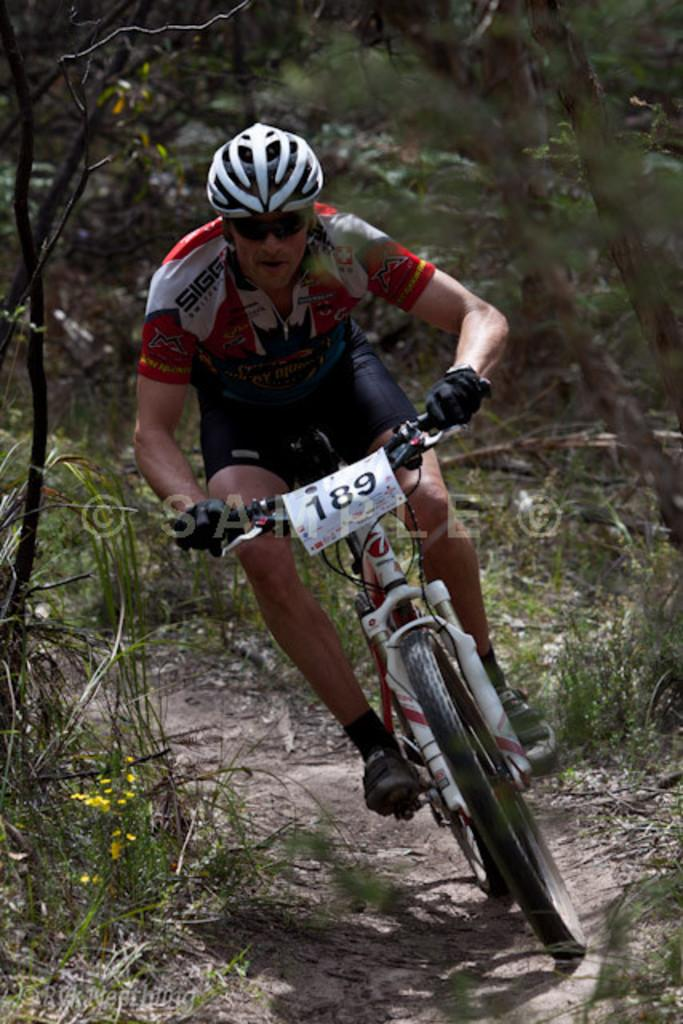What is the man in the image wearing on his head? The man is wearing a helmet in the image. What is the man wearing to protect his eyes? The man is wearing goggles in the image. What type of footwear is the man wearing? The man is wearing shoes in the image. What is the man doing in the image? The man is riding a bicycle in the image. What is the position of the bicycle in the image? The bicycle is on the ground in the image. What can be seen in the background of the image? There are trees in the background of the image. What type of copper material is present in the image? There is no copper material present in the image. Can you describe the field where the man is riding his bicycle? There is no field mentioned or visible in the image; it only shows the man riding a bicycle with trees in the background. 